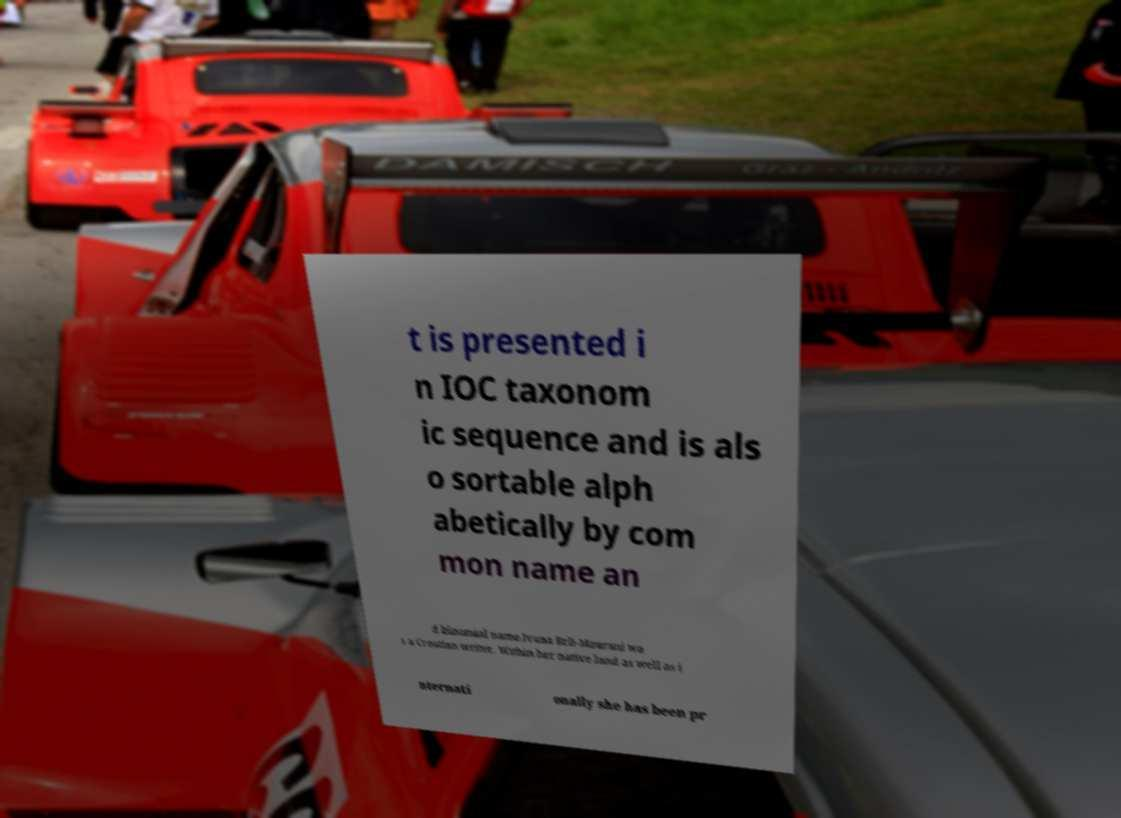There's text embedded in this image that I need extracted. Can you transcribe it verbatim? t is presented i n IOC taxonom ic sequence and is als o sortable alph abetically by com mon name an d binomial name.Ivana Brli-Maurani wa s a Croatian writer. Within her native land as well as i nternati onally she has been pr 